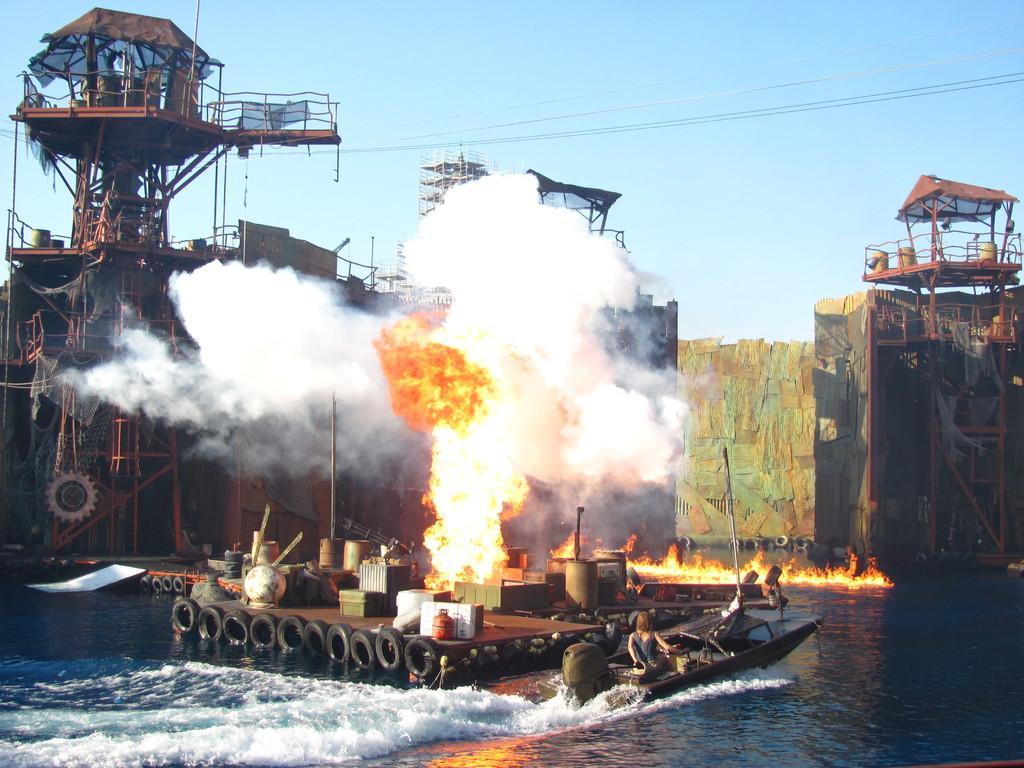How would you summarize this image in a sentence or two? In the image we can see there is a boat standing on the water and there is a person sitting in the boat. There is a building, there is a bridge and there is explosion of fire and smoke in the air. Behind there are buildings and there is clear sky. 